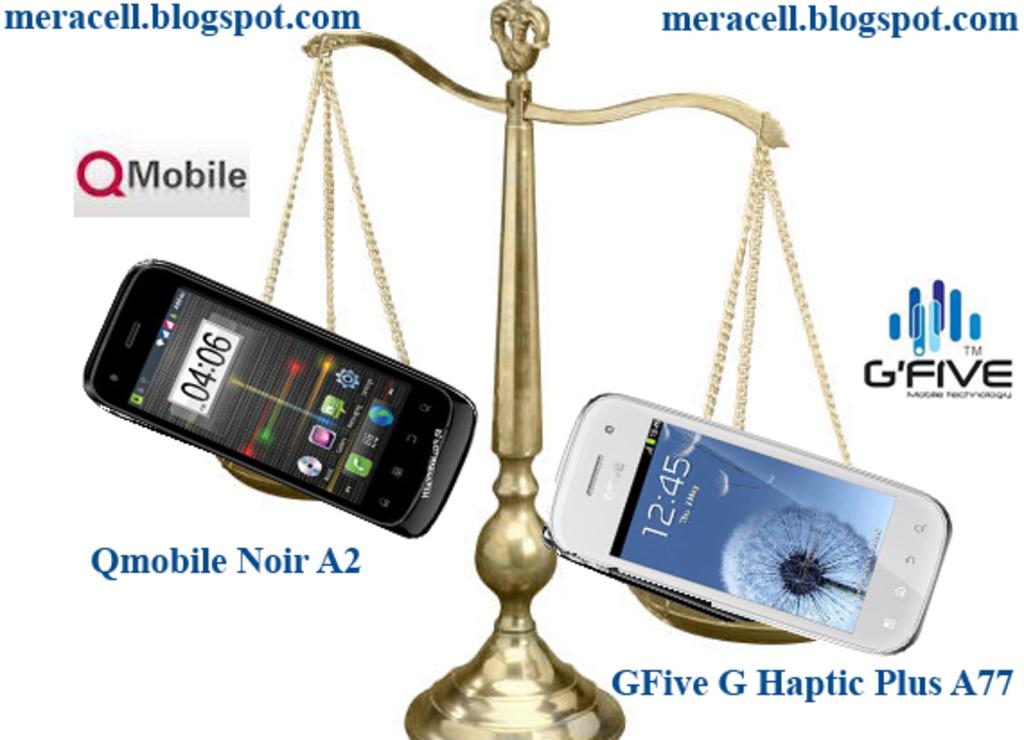G five mobile company?
Your response must be concise. Yes. 